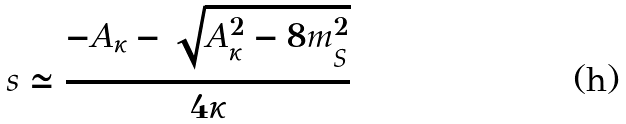<formula> <loc_0><loc_0><loc_500><loc_500>s \simeq \frac { - A _ { \kappa } - \sqrt { A _ { \kappa } ^ { 2 } - 8 m _ { S } ^ { 2 } } } { 4 \kappa }</formula> 